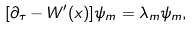Convert formula to latex. <formula><loc_0><loc_0><loc_500><loc_500>[ \partial _ { \tau } - W ^ { \prime } ( x ) ] \psi _ { m } = \lambda _ { m } \psi _ { m } ,</formula> 